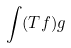<formula> <loc_0><loc_0><loc_500><loc_500>\int ( T f ) g</formula> 